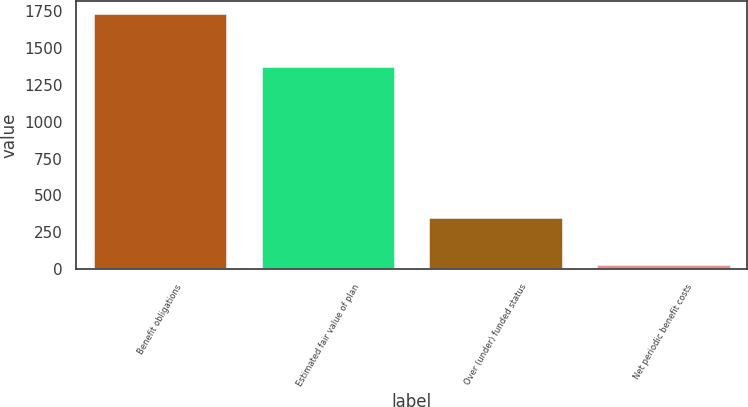<chart> <loc_0><loc_0><loc_500><loc_500><bar_chart><fcel>Benefit obligations<fcel>Estimated fair value of plan<fcel>Over (under) funded status<fcel>Net periodic benefit costs<nl><fcel>1734<fcel>1379<fcel>355<fcel>37<nl></chart> 